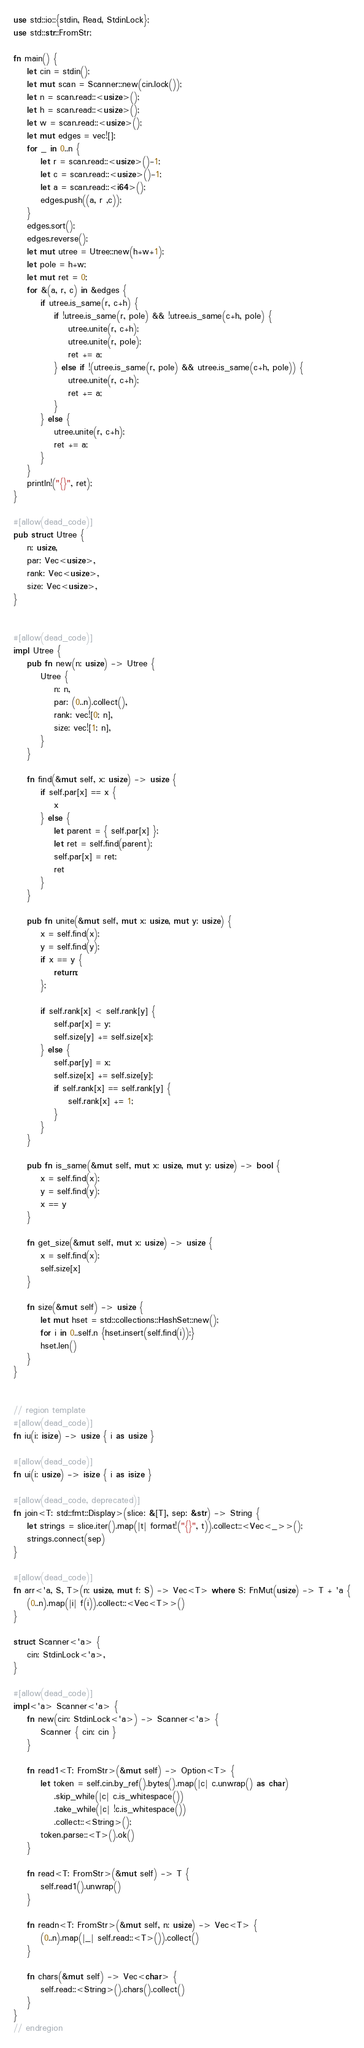<code> <loc_0><loc_0><loc_500><loc_500><_Rust_>use std::io::{stdin, Read, StdinLock};
use std::str::FromStr;

fn main() {
    let cin = stdin();
    let mut scan = Scanner::new(cin.lock());
    let n = scan.read::<usize>();
    let h = scan.read::<usize>();
    let w = scan.read::<usize>();
    let mut edges = vec![];
    for _ in 0..n {
        let r = scan.read::<usize>()-1;
        let c = scan.read::<usize>()-1;
        let a = scan.read::<i64>();
        edges.push((a, r ,c));
    }
    edges.sort();
    edges.reverse();
    let mut utree = Utree::new(h+w+1);
    let pole = h+w;
    let mut ret = 0;
    for &(a, r, c) in &edges {
        if utree.is_same(r, c+h) {
            if !utree.is_same(r, pole) && !utree.is_same(c+h, pole) {
                utree.unite(r, c+h);
                utree.unite(r, pole);
                ret += a;
            } else if !(utree.is_same(r, pole) && utree.is_same(c+h, pole)) {
                utree.unite(r, c+h);
                ret += a;
            }
        } else {
            utree.unite(r, c+h);
            ret += a;
        }
    }
    println!("{}", ret);
}

#[allow(dead_code)]
pub struct Utree {
    n: usize,
    par: Vec<usize>,
    rank: Vec<usize>,
    size: Vec<usize>,
}


#[allow(dead_code)]
impl Utree {
    pub fn new(n: usize) -> Utree {
        Utree {
            n: n,
            par: (0..n).collect(),
            rank: vec![0; n],
            size: vec![1; n],
        }
    }

    fn find(&mut self, x: usize) -> usize {
        if self.par[x] == x {
            x
        } else {
            let parent = { self.par[x] };
            let ret = self.find(parent);
            self.par[x] = ret;
            ret
        }
    }

    pub fn unite(&mut self, mut x: usize, mut y: usize) {
        x = self.find(x);
        y = self.find(y);
        if x == y {
            return;
        };

        if self.rank[x] < self.rank[y] {
            self.par[x] = y;
            self.size[y] += self.size[x];
        } else {
            self.par[y] = x;
            self.size[x] += self.size[y];
            if self.rank[x] == self.rank[y] {
                self.rank[x] += 1;
            }
        }
    }

    pub fn is_same(&mut self, mut x: usize, mut y: usize) -> bool {
        x = self.find(x);
        y = self.find(y);
        x == y
    }

    fn get_size(&mut self, mut x: usize) -> usize {
        x = self.find(x);
        self.size[x]
    }

    fn size(&mut self) -> usize {
        let mut hset = std::collections::HashSet::new();
        for i in 0..self.n {hset.insert(self.find(i));}
        hset.len()
    }
}


// region template
#[allow(dead_code)]
fn iu(i: isize) -> usize { i as usize }

#[allow(dead_code)]
fn ui(i: usize) -> isize { i as isize }

#[allow(dead_code, deprecated)]
fn join<T: std::fmt::Display>(slice: &[T], sep: &str) -> String {
    let strings = slice.iter().map(|t| format!("{}", t)).collect::<Vec<_>>();
    strings.connect(sep)
}

#[allow(dead_code)]
fn arr<'a, S, T>(n: usize, mut f: S) -> Vec<T> where S: FnMut(usize) -> T + 'a {
    (0..n).map(|i| f(i)).collect::<Vec<T>>()
}

struct Scanner<'a> {
    cin: StdinLock<'a>,
}

#[allow(dead_code)]
impl<'a> Scanner<'a> {
    fn new(cin: StdinLock<'a>) -> Scanner<'a> {
        Scanner { cin: cin }
    }

    fn read1<T: FromStr>(&mut self) -> Option<T> {
        let token = self.cin.by_ref().bytes().map(|c| c.unwrap() as char)
            .skip_while(|c| c.is_whitespace())
            .take_while(|c| !c.is_whitespace())
            .collect::<String>();
        token.parse::<T>().ok()
    }

    fn read<T: FromStr>(&mut self) -> T {
        self.read1().unwrap()
    }

    fn readn<T: FromStr>(&mut self, n: usize) -> Vec<T> {
        (0..n).map(|_| self.read::<T>()).collect()
    }

    fn chars(&mut self) -> Vec<char> {
        self.read::<String>().chars().collect()
    }
}
// endregion</code> 